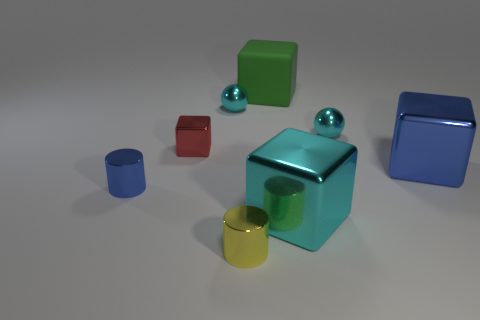Add 2 large blue objects. How many objects exist? 10 Subtract all cylinders. How many objects are left? 6 Subtract 0 red cylinders. How many objects are left? 8 Subtract all tiny cyan metallic cubes. Subtract all green matte cubes. How many objects are left? 7 Add 4 big rubber things. How many big rubber things are left? 5 Add 2 small rubber cylinders. How many small rubber cylinders exist? 2 